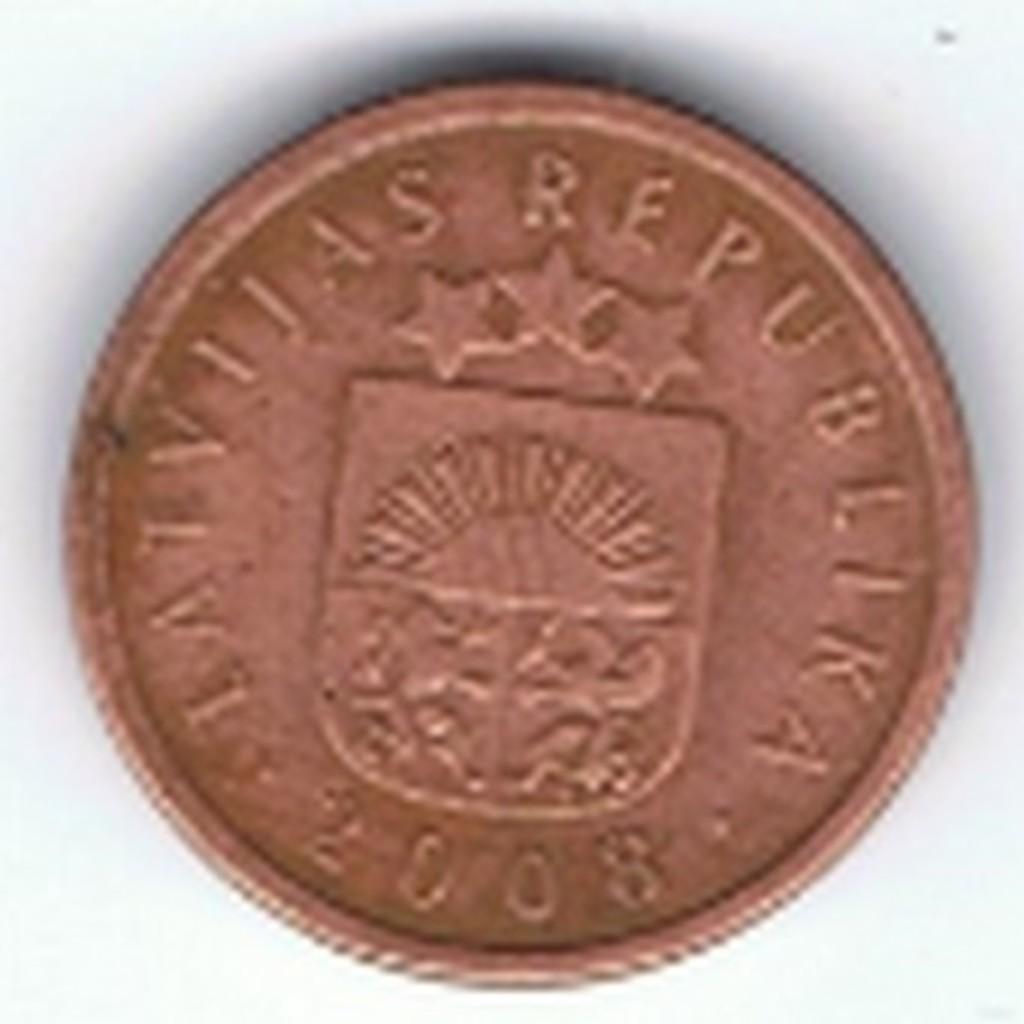What year was the coin pressed?
Ensure brevity in your answer.  2008. What is this a coin for?
Provide a succinct answer. Answering does not require reading text in the image. 